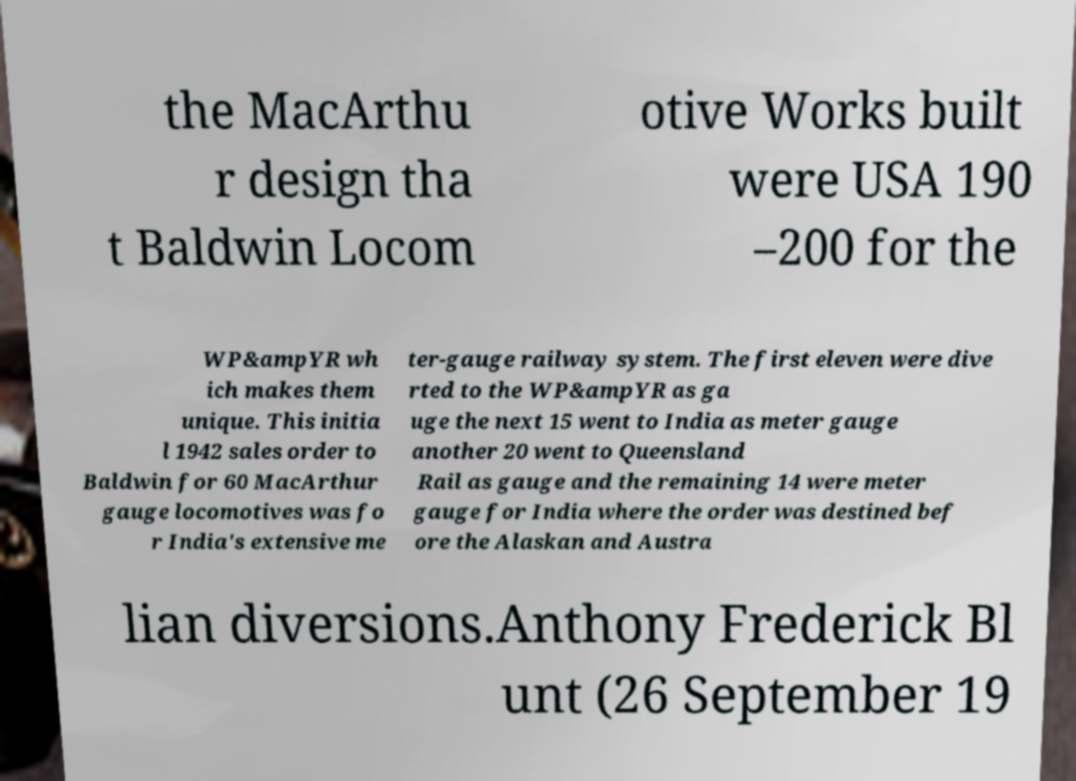Could you assist in decoding the text presented in this image and type it out clearly? the MacArthu r design tha t Baldwin Locom otive Works built were USA 190 –200 for the WP&ampYR wh ich makes them unique. This initia l 1942 sales order to Baldwin for 60 MacArthur gauge locomotives was fo r India's extensive me ter-gauge railway system. The first eleven were dive rted to the WP&ampYR as ga uge the next 15 went to India as meter gauge another 20 went to Queensland Rail as gauge and the remaining 14 were meter gauge for India where the order was destined bef ore the Alaskan and Austra lian diversions.Anthony Frederick Bl unt (26 September 19 